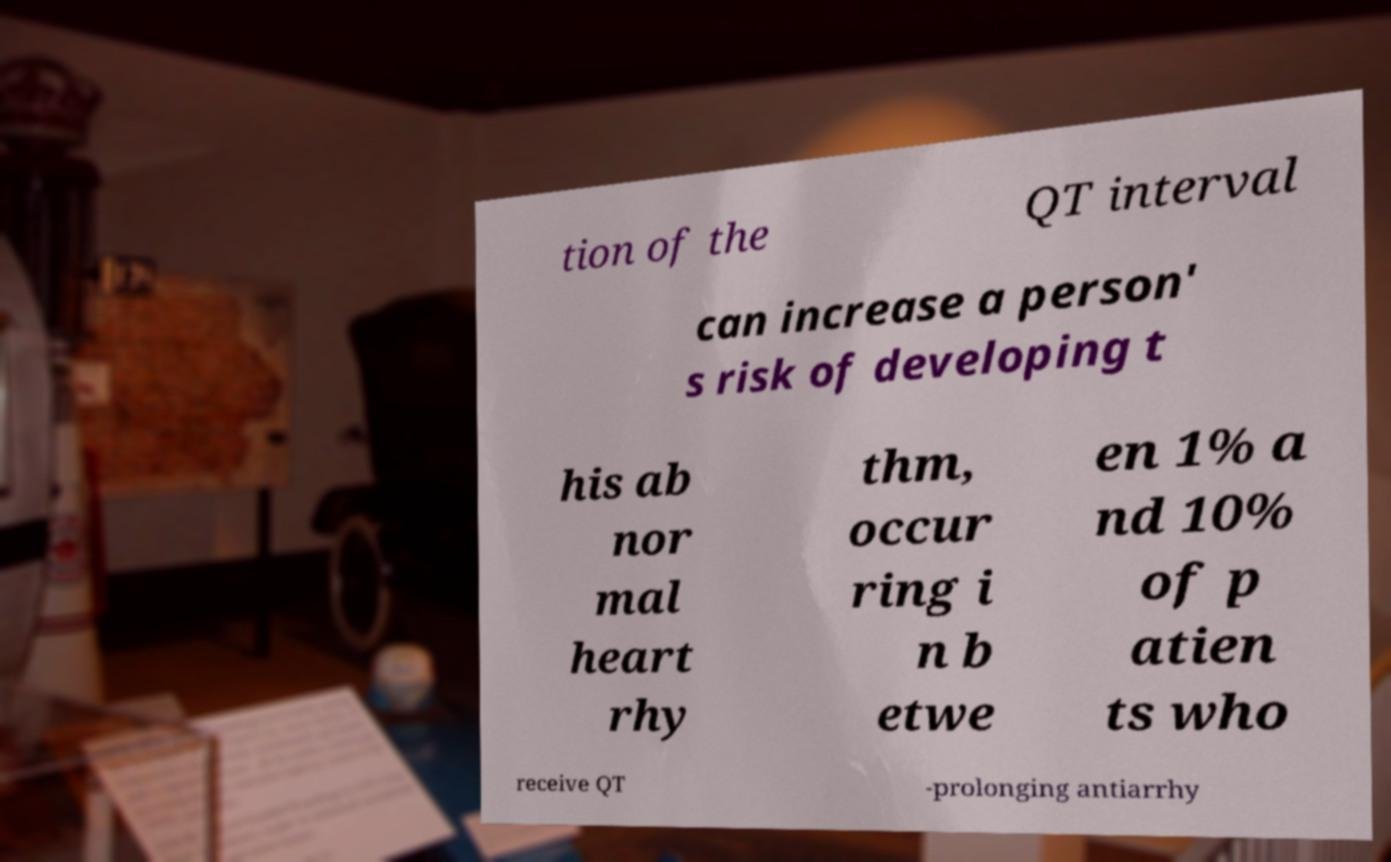I need the written content from this picture converted into text. Can you do that? tion of the QT interval can increase a person' s risk of developing t his ab nor mal heart rhy thm, occur ring i n b etwe en 1% a nd 10% of p atien ts who receive QT -prolonging antiarrhy 